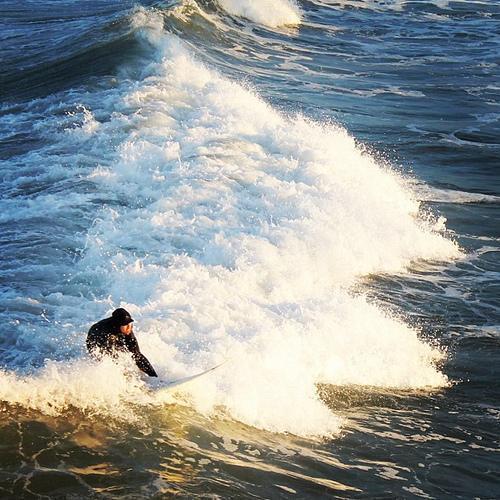How many surfers are there?
Give a very brief answer. 1. 